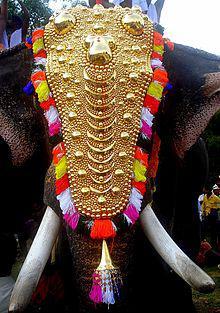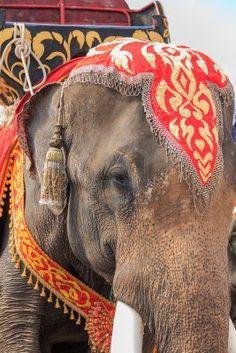The first image is the image on the left, the second image is the image on the right. For the images displayed, is the sentence "An image shows a camera-facing tusked elephant wearing an ornate dimensional metallic-look head covering." factually correct? Answer yes or no. Yes. The first image is the image on the left, the second image is the image on the right. Evaluate the accuracy of this statement regarding the images: "One elephant wears primarily orange decorations and has something trimmed with bell shapes around its neck.". Is it true? Answer yes or no. Yes. The first image is the image on the left, the second image is the image on the right. Assess this claim about the two images: "At least one person is standing near an elephant in the image on the right.". Correct or not? Answer yes or no. No. The first image is the image on the left, the second image is the image on the right. Evaluate the accuracy of this statement regarding the images: "An elephant in one image is wearing a colorful head cloth that descends over its forehead to a point between its eyes, so that its eyes are still visible". Is it true? Answer yes or no. Yes. 